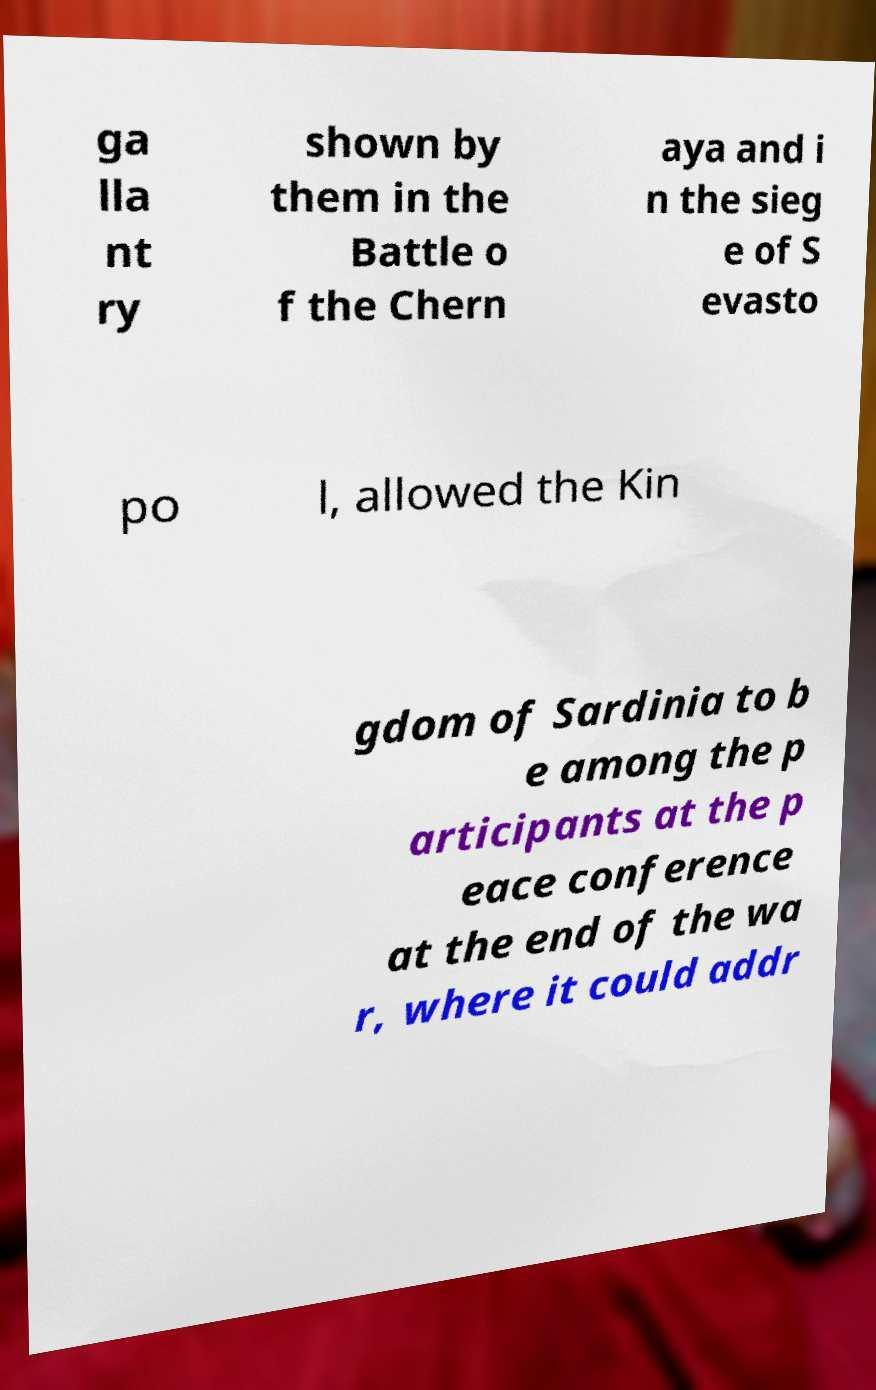Can you accurately transcribe the text from the provided image for me? ga lla nt ry shown by them in the Battle o f the Chern aya and i n the sieg e of S evasto po l, allowed the Kin gdom of Sardinia to b e among the p articipants at the p eace conference at the end of the wa r, where it could addr 